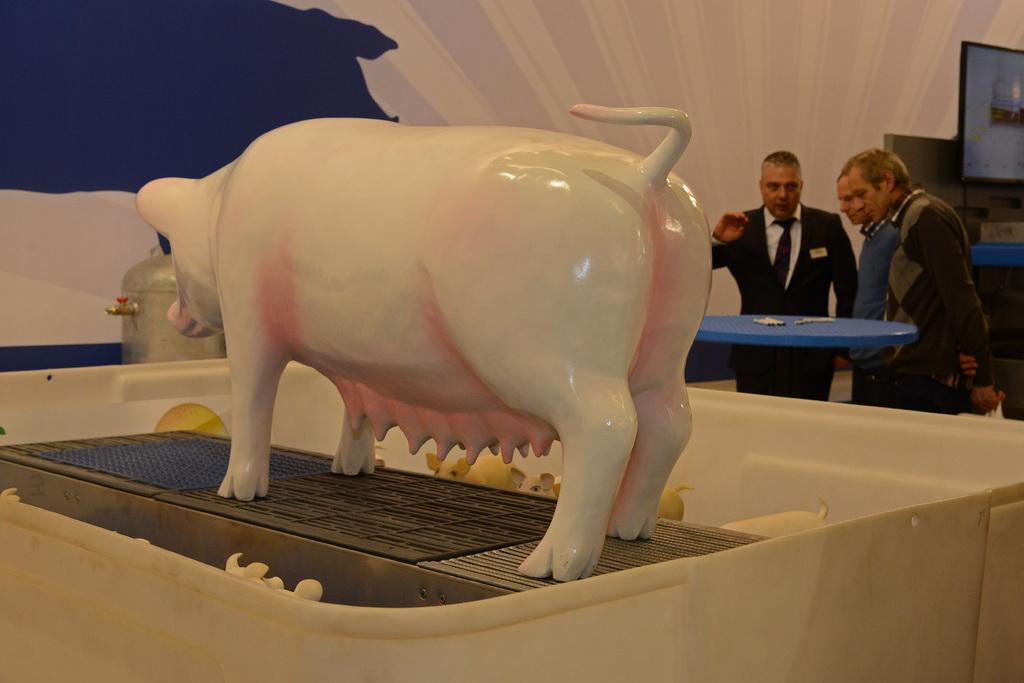What is the main subject of the image? There is a porcelain statue of a pig in the image. Where is the statue located? The statue is placed on a table. What can be seen in the background of the image? In the background, there are three men standing in front of a table. What are the men doing in the image? The men are talking. What color is the watch worn by the pig in the image? There is no watch present in the image, and the pig is a porcelain statue, not a living creature. 